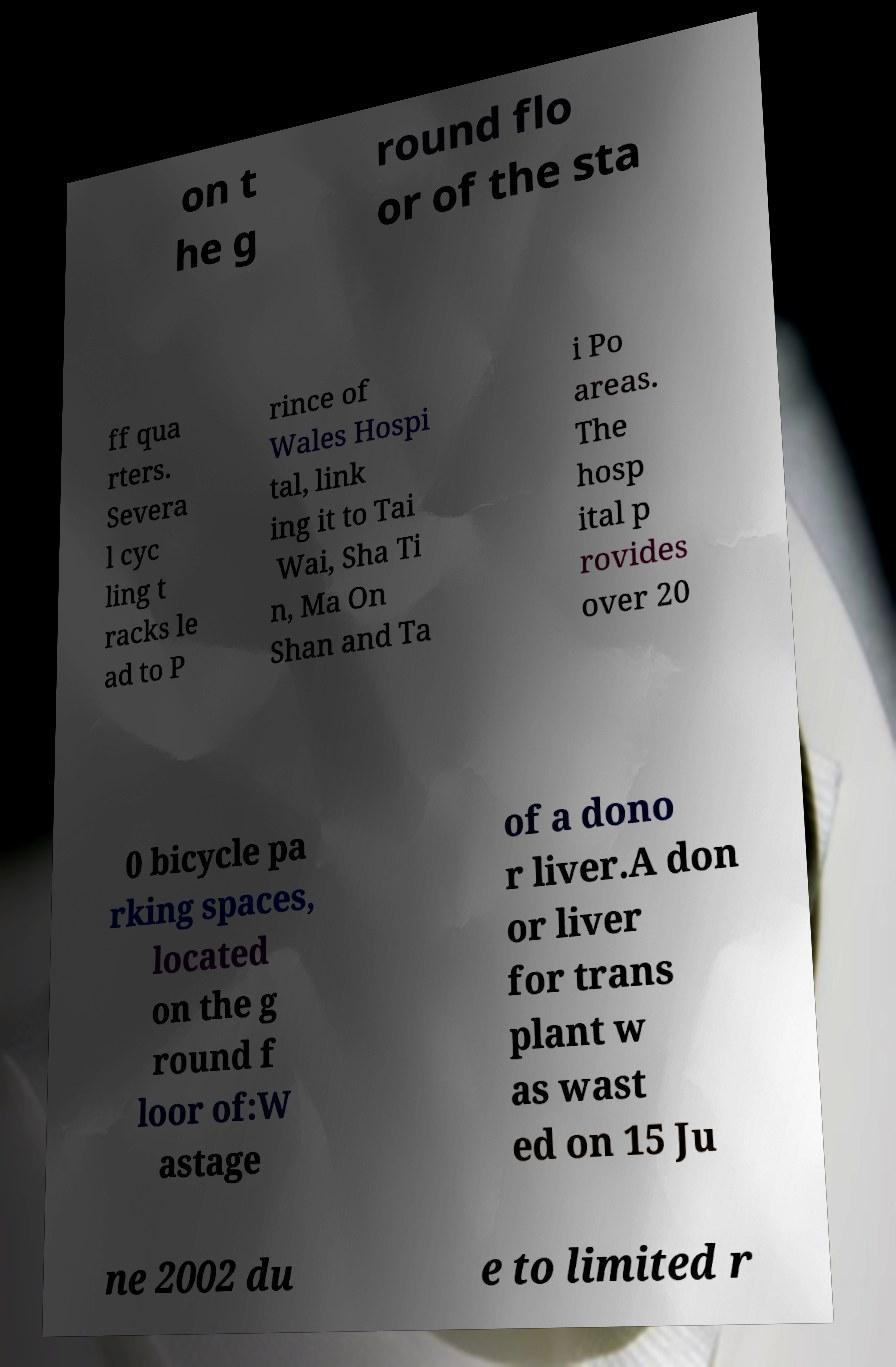Could you extract and type out the text from this image? on t he g round flo or of the sta ff qua rters. Severa l cyc ling t racks le ad to P rince of Wales Hospi tal, link ing it to Tai Wai, Sha Ti n, Ma On Shan and Ta i Po areas. The hosp ital p rovides over 20 0 bicycle pa rking spaces, located on the g round f loor of:W astage of a dono r liver.A don or liver for trans plant w as wast ed on 15 Ju ne 2002 du e to limited r 